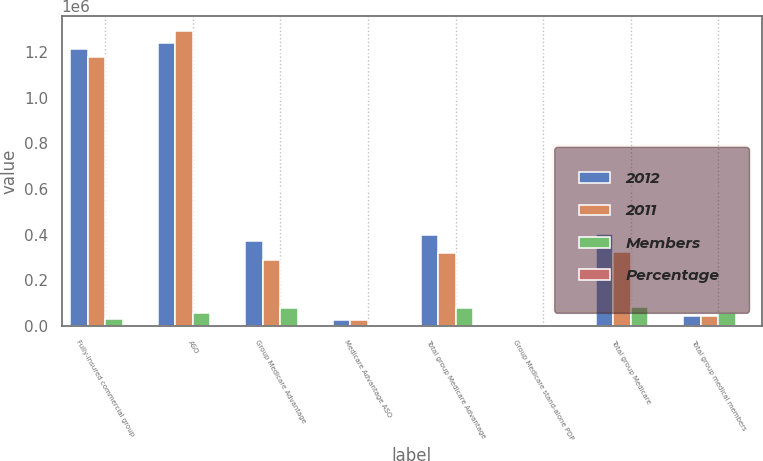Convert chart. <chart><loc_0><loc_0><loc_500><loc_500><stacked_bar_chart><ecel><fcel>Fully-insured commercial group<fcel>ASO<fcel>Group Medicare Advantage<fcel>Medicare Advantage ASO<fcel>Total group Medicare Advantage<fcel>Group Medicare stand-alone PDP<fcel>Total group Medicare<fcel>Total group medical members<nl><fcel>2012<fcel>1.2118e+06<fcel>1.2377e+06<fcel>370800<fcel>27700<fcel>398500<fcel>4400<fcel>402900<fcel>43100<nl><fcel>2011<fcel>1.1802e+06<fcel>1.2923e+06<fcel>290600<fcel>27600<fcel>318200<fcel>4200<fcel>322400<fcel>43100<nl><fcel>Members<fcel>31600<fcel>54600<fcel>80200<fcel>100<fcel>80300<fcel>200<fcel>80500<fcel>57500<nl><fcel>Percentage<fcel>2.7<fcel>4.2<fcel>27.6<fcel>0.4<fcel>25.2<fcel>4.8<fcel>25<fcel>2.1<nl></chart> 